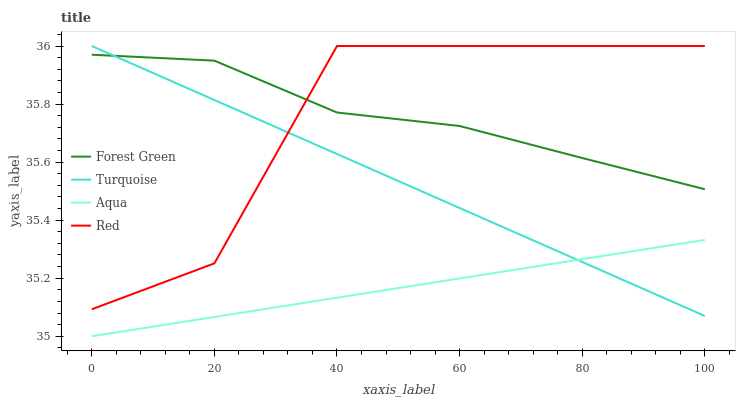Does Turquoise have the minimum area under the curve?
Answer yes or no. No. Does Turquoise have the maximum area under the curve?
Answer yes or no. No. Is Aqua the smoothest?
Answer yes or no. No. Is Aqua the roughest?
Answer yes or no. No. Does Turquoise have the lowest value?
Answer yes or no. No. Does Aqua have the highest value?
Answer yes or no. No. Is Aqua less than Forest Green?
Answer yes or no. Yes. Is Red greater than Aqua?
Answer yes or no. Yes. Does Aqua intersect Forest Green?
Answer yes or no. No. 